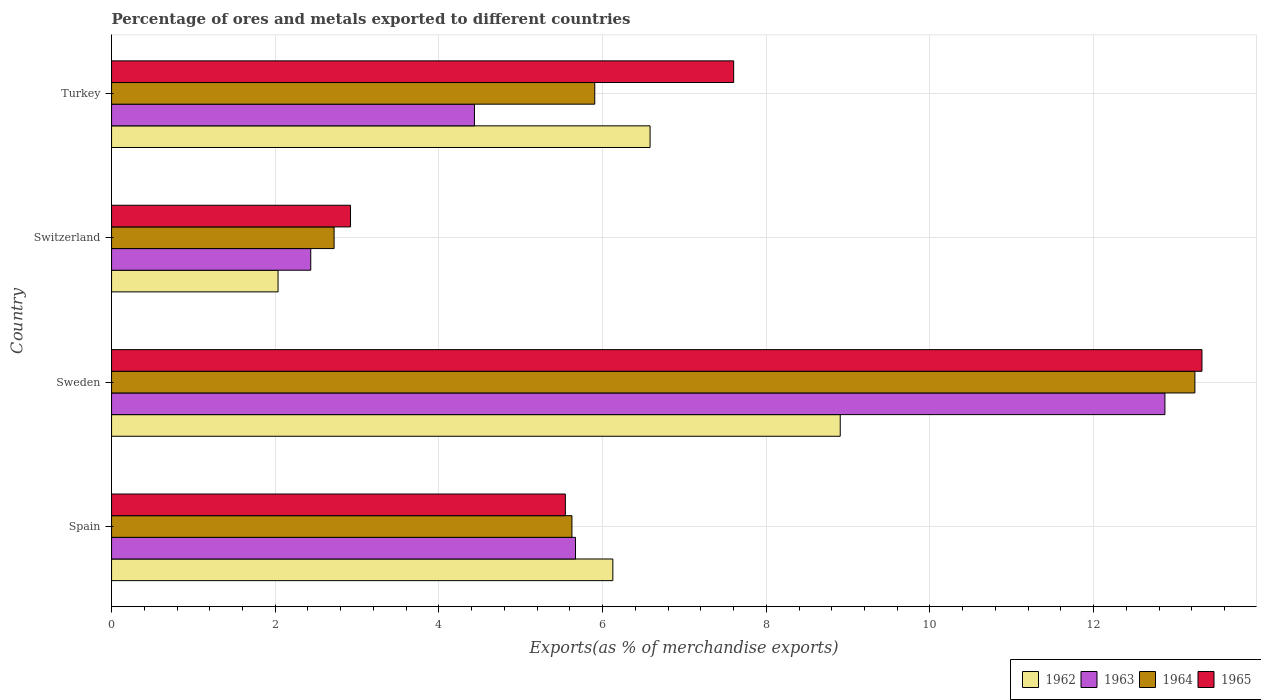How many different coloured bars are there?
Provide a short and direct response. 4. How many groups of bars are there?
Provide a succinct answer. 4. Are the number of bars per tick equal to the number of legend labels?
Make the answer very short. Yes. How many bars are there on the 2nd tick from the top?
Make the answer very short. 4. In how many cases, is the number of bars for a given country not equal to the number of legend labels?
Make the answer very short. 0. What is the percentage of exports to different countries in 1963 in Sweden?
Provide a short and direct response. 12.87. Across all countries, what is the maximum percentage of exports to different countries in 1965?
Your answer should be very brief. 13.32. Across all countries, what is the minimum percentage of exports to different countries in 1964?
Make the answer very short. 2.72. In which country was the percentage of exports to different countries in 1963 maximum?
Offer a very short reply. Sweden. In which country was the percentage of exports to different countries in 1965 minimum?
Your answer should be compact. Switzerland. What is the total percentage of exports to different countries in 1964 in the graph?
Make the answer very short. 27.49. What is the difference between the percentage of exports to different countries in 1962 in Switzerland and that in Turkey?
Your response must be concise. -4.55. What is the difference between the percentage of exports to different countries in 1964 in Switzerland and the percentage of exports to different countries in 1962 in Sweden?
Give a very brief answer. -6.18. What is the average percentage of exports to different countries in 1962 per country?
Provide a succinct answer. 5.91. What is the difference between the percentage of exports to different countries in 1962 and percentage of exports to different countries in 1963 in Turkey?
Your response must be concise. 2.15. In how many countries, is the percentage of exports to different countries in 1962 greater than 3.2 %?
Give a very brief answer. 3. What is the ratio of the percentage of exports to different countries in 1964 in Switzerland to that in Turkey?
Your response must be concise. 0.46. Is the percentage of exports to different countries in 1965 in Spain less than that in Turkey?
Offer a terse response. Yes. Is the difference between the percentage of exports to different countries in 1962 in Spain and Switzerland greater than the difference between the percentage of exports to different countries in 1963 in Spain and Switzerland?
Provide a succinct answer. Yes. What is the difference between the highest and the second highest percentage of exports to different countries in 1965?
Keep it short and to the point. 5.72. What is the difference between the highest and the lowest percentage of exports to different countries in 1963?
Offer a very short reply. 10.44. In how many countries, is the percentage of exports to different countries in 1965 greater than the average percentage of exports to different countries in 1965 taken over all countries?
Your answer should be very brief. 2. What does the 4th bar from the top in Turkey represents?
Offer a very short reply. 1962. Is it the case that in every country, the sum of the percentage of exports to different countries in 1965 and percentage of exports to different countries in 1963 is greater than the percentage of exports to different countries in 1962?
Keep it short and to the point. Yes. How many bars are there?
Ensure brevity in your answer.  16. Are all the bars in the graph horizontal?
Your response must be concise. Yes. How many countries are there in the graph?
Make the answer very short. 4. Does the graph contain grids?
Your answer should be compact. Yes. Where does the legend appear in the graph?
Give a very brief answer. Bottom right. How many legend labels are there?
Keep it short and to the point. 4. How are the legend labels stacked?
Keep it short and to the point. Horizontal. What is the title of the graph?
Offer a terse response. Percentage of ores and metals exported to different countries. What is the label or title of the X-axis?
Offer a terse response. Exports(as % of merchandise exports). What is the label or title of the Y-axis?
Make the answer very short. Country. What is the Exports(as % of merchandise exports) in 1962 in Spain?
Offer a very short reply. 6.13. What is the Exports(as % of merchandise exports) in 1963 in Spain?
Offer a very short reply. 5.67. What is the Exports(as % of merchandise exports) of 1964 in Spain?
Your response must be concise. 5.63. What is the Exports(as % of merchandise exports) in 1965 in Spain?
Offer a terse response. 5.55. What is the Exports(as % of merchandise exports) of 1962 in Sweden?
Your response must be concise. 8.9. What is the Exports(as % of merchandise exports) of 1963 in Sweden?
Offer a terse response. 12.87. What is the Exports(as % of merchandise exports) in 1964 in Sweden?
Your response must be concise. 13.24. What is the Exports(as % of merchandise exports) of 1965 in Sweden?
Make the answer very short. 13.32. What is the Exports(as % of merchandise exports) of 1962 in Switzerland?
Offer a very short reply. 2.03. What is the Exports(as % of merchandise exports) of 1963 in Switzerland?
Make the answer very short. 2.43. What is the Exports(as % of merchandise exports) of 1964 in Switzerland?
Give a very brief answer. 2.72. What is the Exports(as % of merchandise exports) in 1965 in Switzerland?
Give a very brief answer. 2.92. What is the Exports(as % of merchandise exports) of 1962 in Turkey?
Keep it short and to the point. 6.58. What is the Exports(as % of merchandise exports) of 1963 in Turkey?
Your response must be concise. 4.43. What is the Exports(as % of merchandise exports) of 1964 in Turkey?
Ensure brevity in your answer.  5.9. What is the Exports(as % of merchandise exports) of 1965 in Turkey?
Give a very brief answer. 7.6. Across all countries, what is the maximum Exports(as % of merchandise exports) of 1962?
Your response must be concise. 8.9. Across all countries, what is the maximum Exports(as % of merchandise exports) in 1963?
Ensure brevity in your answer.  12.87. Across all countries, what is the maximum Exports(as % of merchandise exports) of 1964?
Your response must be concise. 13.24. Across all countries, what is the maximum Exports(as % of merchandise exports) of 1965?
Your answer should be compact. 13.32. Across all countries, what is the minimum Exports(as % of merchandise exports) of 1962?
Provide a short and direct response. 2.03. Across all countries, what is the minimum Exports(as % of merchandise exports) of 1963?
Your answer should be very brief. 2.43. Across all countries, what is the minimum Exports(as % of merchandise exports) of 1964?
Offer a very short reply. 2.72. Across all countries, what is the minimum Exports(as % of merchandise exports) in 1965?
Give a very brief answer. 2.92. What is the total Exports(as % of merchandise exports) in 1962 in the graph?
Give a very brief answer. 23.64. What is the total Exports(as % of merchandise exports) in 1963 in the graph?
Offer a terse response. 25.41. What is the total Exports(as % of merchandise exports) in 1964 in the graph?
Provide a short and direct response. 27.49. What is the total Exports(as % of merchandise exports) in 1965 in the graph?
Make the answer very short. 29.39. What is the difference between the Exports(as % of merchandise exports) of 1962 in Spain and that in Sweden?
Your answer should be very brief. -2.78. What is the difference between the Exports(as % of merchandise exports) of 1963 in Spain and that in Sweden?
Provide a short and direct response. -7.2. What is the difference between the Exports(as % of merchandise exports) in 1964 in Spain and that in Sweden?
Ensure brevity in your answer.  -7.61. What is the difference between the Exports(as % of merchandise exports) in 1965 in Spain and that in Sweden?
Ensure brevity in your answer.  -7.78. What is the difference between the Exports(as % of merchandise exports) in 1962 in Spain and that in Switzerland?
Ensure brevity in your answer.  4.09. What is the difference between the Exports(as % of merchandise exports) of 1963 in Spain and that in Switzerland?
Keep it short and to the point. 3.24. What is the difference between the Exports(as % of merchandise exports) of 1964 in Spain and that in Switzerland?
Your response must be concise. 2.91. What is the difference between the Exports(as % of merchandise exports) of 1965 in Spain and that in Switzerland?
Ensure brevity in your answer.  2.63. What is the difference between the Exports(as % of merchandise exports) of 1962 in Spain and that in Turkey?
Your answer should be compact. -0.46. What is the difference between the Exports(as % of merchandise exports) of 1963 in Spain and that in Turkey?
Give a very brief answer. 1.23. What is the difference between the Exports(as % of merchandise exports) of 1964 in Spain and that in Turkey?
Provide a succinct answer. -0.28. What is the difference between the Exports(as % of merchandise exports) in 1965 in Spain and that in Turkey?
Ensure brevity in your answer.  -2.06. What is the difference between the Exports(as % of merchandise exports) in 1962 in Sweden and that in Switzerland?
Keep it short and to the point. 6.87. What is the difference between the Exports(as % of merchandise exports) of 1963 in Sweden and that in Switzerland?
Your answer should be compact. 10.44. What is the difference between the Exports(as % of merchandise exports) in 1964 in Sweden and that in Switzerland?
Make the answer very short. 10.52. What is the difference between the Exports(as % of merchandise exports) in 1965 in Sweden and that in Switzerland?
Your answer should be compact. 10.4. What is the difference between the Exports(as % of merchandise exports) of 1962 in Sweden and that in Turkey?
Your answer should be compact. 2.32. What is the difference between the Exports(as % of merchandise exports) of 1963 in Sweden and that in Turkey?
Provide a short and direct response. 8.44. What is the difference between the Exports(as % of merchandise exports) in 1964 in Sweden and that in Turkey?
Provide a short and direct response. 7.33. What is the difference between the Exports(as % of merchandise exports) in 1965 in Sweden and that in Turkey?
Ensure brevity in your answer.  5.72. What is the difference between the Exports(as % of merchandise exports) of 1962 in Switzerland and that in Turkey?
Provide a succinct answer. -4.55. What is the difference between the Exports(as % of merchandise exports) in 1963 in Switzerland and that in Turkey?
Your response must be concise. -2. What is the difference between the Exports(as % of merchandise exports) in 1964 in Switzerland and that in Turkey?
Provide a short and direct response. -3.19. What is the difference between the Exports(as % of merchandise exports) in 1965 in Switzerland and that in Turkey?
Your answer should be compact. -4.68. What is the difference between the Exports(as % of merchandise exports) in 1962 in Spain and the Exports(as % of merchandise exports) in 1963 in Sweden?
Your answer should be compact. -6.75. What is the difference between the Exports(as % of merchandise exports) of 1962 in Spain and the Exports(as % of merchandise exports) of 1964 in Sweden?
Your response must be concise. -7.11. What is the difference between the Exports(as % of merchandise exports) in 1962 in Spain and the Exports(as % of merchandise exports) in 1965 in Sweden?
Your answer should be very brief. -7.2. What is the difference between the Exports(as % of merchandise exports) in 1963 in Spain and the Exports(as % of merchandise exports) in 1964 in Sweden?
Give a very brief answer. -7.57. What is the difference between the Exports(as % of merchandise exports) in 1963 in Spain and the Exports(as % of merchandise exports) in 1965 in Sweden?
Ensure brevity in your answer.  -7.65. What is the difference between the Exports(as % of merchandise exports) in 1964 in Spain and the Exports(as % of merchandise exports) in 1965 in Sweden?
Make the answer very short. -7.7. What is the difference between the Exports(as % of merchandise exports) in 1962 in Spain and the Exports(as % of merchandise exports) in 1963 in Switzerland?
Provide a succinct answer. 3.69. What is the difference between the Exports(as % of merchandise exports) in 1962 in Spain and the Exports(as % of merchandise exports) in 1964 in Switzerland?
Ensure brevity in your answer.  3.41. What is the difference between the Exports(as % of merchandise exports) of 1962 in Spain and the Exports(as % of merchandise exports) of 1965 in Switzerland?
Offer a very short reply. 3.21. What is the difference between the Exports(as % of merchandise exports) of 1963 in Spain and the Exports(as % of merchandise exports) of 1964 in Switzerland?
Provide a short and direct response. 2.95. What is the difference between the Exports(as % of merchandise exports) in 1963 in Spain and the Exports(as % of merchandise exports) in 1965 in Switzerland?
Offer a very short reply. 2.75. What is the difference between the Exports(as % of merchandise exports) in 1964 in Spain and the Exports(as % of merchandise exports) in 1965 in Switzerland?
Provide a succinct answer. 2.71. What is the difference between the Exports(as % of merchandise exports) of 1962 in Spain and the Exports(as % of merchandise exports) of 1963 in Turkey?
Your answer should be compact. 1.69. What is the difference between the Exports(as % of merchandise exports) in 1962 in Spain and the Exports(as % of merchandise exports) in 1964 in Turkey?
Your response must be concise. 0.22. What is the difference between the Exports(as % of merchandise exports) of 1962 in Spain and the Exports(as % of merchandise exports) of 1965 in Turkey?
Make the answer very short. -1.48. What is the difference between the Exports(as % of merchandise exports) of 1963 in Spain and the Exports(as % of merchandise exports) of 1964 in Turkey?
Ensure brevity in your answer.  -0.23. What is the difference between the Exports(as % of merchandise exports) in 1963 in Spain and the Exports(as % of merchandise exports) in 1965 in Turkey?
Give a very brief answer. -1.93. What is the difference between the Exports(as % of merchandise exports) in 1964 in Spain and the Exports(as % of merchandise exports) in 1965 in Turkey?
Make the answer very short. -1.98. What is the difference between the Exports(as % of merchandise exports) in 1962 in Sweden and the Exports(as % of merchandise exports) in 1963 in Switzerland?
Offer a very short reply. 6.47. What is the difference between the Exports(as % of merchandise exports) of 1962 in Sweden and the Exports(as % of merchandise exports) of 1964 in Switzerland?
Your answer should be very brief. 6.18. What is the difference between the Exports(as % of merchandise exports) in 1962 in Sweden and the Exports(as % of merchandise exports) in 1965 in Switzerland?
Offer a terse response. 5.98. What is the difference between the Exports(as % of merchandise exports) of 1963 in Sweden and the Exports(as % of merchandise exports) of 1964 in Switzerland?
Give a very brief answer. 10.15. What is the difference between the Exports(as % of merchandise exports) in 1963 in Sweden and the Exports(as % of merchandise exports) in 1965 in Switzerland?
Offer a terse response. 9.95. What is the difference between the Exports(as % of merchandise exports) in 1964 in Sweden and the Exports(as % of merchandise exports) in 1965 in Switzerland?
Give a very brief answer. 10.32. What is the difference between the Exports(as % of merchandise exports) of 1962 in Sweden and the Exports(as % of merchandise exports) of 1963 in Turkey?
Provide a short and direct response. 4.47. What is the difference between the Exports(as % of merchandise exports) in 1962 in Sweden and the Exports(as % of merchandise exports) in 1964 in Turkey?
Your answer should be compact. 3. What is the difference between the Exports(as % of merchandise exports) of 1962 in Sweden and the Exports(as % of merchandise exports) of 1965 in Turkey?
Ensure brevity in your answer.  1.3. What is the difference between the Exports(as % of merchandise exports) of 1963 in Sweden and the Exports(as % of merchandise exports) of 1964 in Turkey?
Provide a short and direct response. 6.97. What is the difference between the Exports(as % of merchandise exports) of 1963 in Sweden and the Exports(as % of merchandise exports) of 1965 in Turkey?
Offer a very short reply. 5.27. What is the difference between the Exports(as % of merchandise exports) of 1964 in Sweden and the Exports(as % of merchandise exports) of 1965 in Turkey?
Ensure brevity in your answer.  5.64. What is the difference between the Exports(as % of merchandise exports) in 1962 in Switzerland and the Exports(as % of merchandise exports) in 1963 in Turkey?
Provide a succinct answer. -2.4. What is the difference between the Exports(as % of merchandise exports) of 1962 in Switzerland and the Exports(as % of merchandise exports) of 1964 in Turkey?
Make the answer very short. -3.87. What is the difference between the Exports(as % of merchandise exports) in 1962 in Switzerland and the Exports(as % of merchandise exports) in 1965 in Turkey?
Provide a short and direct response. -5.57. What is the difference between the Exports(as % of merchandise exports) of 1963 in Switzerland and the Exports(as % of merchandise exports) of 1964 in Turkey?
Offer a very short reply. -3.47. What is the difference between the Exports(as % of merchandise exports) in 1963 in Switzerland and the Exports(as % of merchandise exports) in 1965 in Turkey?
Offer a very short reply. -5.17. What is the difference between the Exports(as % of merchandise exports) in 1964 in Switzerland and the Exports(as % of merchandise exports) in 1965 in Turkey?
Ensure brevity in your answer.  -4.88. What is the average Exports(as % of merchandise exports) of 1962 per country?
Your answer should be compact. 5.91. What is the average Exports(as % of merchandise exports) in 1963 per country?
Provide a short and direct response. 6.35. What is the average Exports(as % of merchandise exports) in 1964 per country?
Ensure brevity in your answer.  6.87. What is the average Exports(as % of merchandise exports) in 1965 per country?
Make the answer very short. 7.35. What is the difference between the Exports(as % of merchandise exports) of 1962 and Exports(as % of merchandise exports) of 1963 in Spain?
Your answer should be compact. 0.46. What is the difference between the Exports(as % of merchandise exports) of 1962 and Exports(as % of merchandise exports) of 1964 in Spain?
Offer a terse response. 0.5. What is the difference between the Exports(as % of merchandise exports) of 1962 and Exports(as % of merchandise exports) of 1965 in Spain?
Your response must be concise. 0.58. What is the difference between the Exports(as % of merchandise exports) of 1963 and Exports(as % of merchandise exports) of 1964 in Spain?
Your answer should be very brief. 0.04. What is the difference between the Exports(as % of merchandise exports) in 1963 and Exports(as % of merchandise exports) in 1965 in Spain?
Give a very brief answer. 0.12. What is the difference between the Exports(as % of merchandise exports) of 1964 and Exports(as % of merchandise exports) of 1965 in Spain?
Make the answer very short. 0.08. What is the difference between the Exports(as % of merchandise exports) of 1962 and Exports(as % of merchandise exports) of 1963 in Sweden?
Keep it short and to the point. -3.97. What is the difference between the Exports(as % of merchandise exports) in 1962 and Exports(as % of merchandise exports) in 1964 in Sweden?
Your response must be concise. -4.33. What is the difference between the Exports(as % of merchandise exports) of 1962 and Exports(as % of merchandise exports) of 1965 in Sweden?
Provide a short and direct response. -4.42. What is the difference between the Exports(as % of merchandise exports) of 1963 and Exports(as % of merchandise exports) of 1964 in Sweden?
Your answer should be compact. -0.37. What is the difference between the Exports(as % of merchandise exports) of 1963 and Exports(as % of merchandise exports) of 1965 in Sweden?
Give a very brief answer. -0.45. What is the difference between the Exports(as % of merchandise exports) of 1964 and Exports(as % of merchandise exports) of 1965 in Sweden?
Ensure brevity in your answer.  -0.09. What is the difference between the Exports(as % of merchandise exports) in 1962 and Exports(as % of merchandise exports) in 1963 in Switzerland?
Provide a succinct answer. -0.4. What is the difference between the Exports(as % of merchandise exports) of 1962 and Exports(as % of merchandise exports) of 1964 in Switzerland?
Make the answer very short. -0.68. What is the difference between the Exports(as % of merchandise exports) in 1962 and Exports(as % of merchandise exports) in 1965 in Switzerland?
Keep it short and to the point. -0.89. What is the difference between the Exports(as % of merchandise exports) of 1963 and Exports(as % of merchandise exports) of 1964 in Switzerland?
Make the answer very short. -0.29. What is the difference between the Exports(as % of merchandise exports) in 1963 and Exports(as % of merchandise exports) in 1965 in Switzerland?
Keep it short and to the point. -0.49. What is the difference between the Exports(as % of merchandise exports) of 1964 and Exports(as % of merchandise exports) of 1965 in Switzerland?
Your response must be concise. -0.2. What is the difference between the Exports(as % of merchandise exports) of 1962 and Exports(as % of merchandise exports) of 1963 in Turkey?
Your answer should be very brief. 2.15. What is the difference between the Exports(as % of merchandise exports) in 1962 and Exports(as % of merchandise exports) in 1964 in Turkey?
Your answer should be compact. 0.68. What is the difference between the Exports(as % of merchandise exports) in 1962 and Exports(as % of merchandise exports) in 1965 in Turkey?
Your answer should be compact. -1.02. What is the difference between the Exports(as % of merchandise exports) in 1963 and Exports(as % of merchandise exports) in 1964 in Turkey?
Ensure brevity in your answer.  -1.47. What is the difference between the Exports(as % of merchandise exports) in 1963 and Exports(as % of merchandise exports) in 1965 in Turkey?
Offer a terse response. -3.17. What is the difference between the Exports(as % of merchandise exports) of 1964 and Exports(as % of merchandise exports) of 1965 in Turkey?
Your answer should be very brief. -1.7. What is the ratio of the Exports(as % of merchandise exports) of 1962 in Spain to that in Sweden?
Your response must be concise. 0.69. What is the ratio of the Exports(as % of merchandise exports) of 1963 in Spain to that in Sweden?
Your answer should be very brief. 0.44. What is the ratio of the Exports(as % of merchandise exports) in 1964 in Spain to that in Sweden?
Offer a terse response. 0.42. What is the ratio of the Exports(as % of merchandise exports) of 1965 in Spain to that in Sweden?
Your answer should be compact. 0.42. What is the ratio of the Exports(as % of merchandise exports) in 1962 in Spain to that in Switzerland?
Offer a very short reply. 3.01. What is the ratio of the Exports(as % of merchandise exports) in 1963 in Spain to that in Switzerland?
Keep it short and to the point. 2.33. What is the ratio of the Exports(as % of merchandise exports) in 1964 in Spain to that in Switzerland?
Give a very brief answer. 2.07. What is the ratio of the Exports(as % of merchandise exports) in 1965 in Spain to that in Switzerland?
Your response must be concise. 1.9. What is the ratio of the Exports(as % of merchandise exports) in 1962 in Spain to that in Turkey?
Ensure brevity in your answer.  0.93. What is the ratio of the Exports(as % of merchandise exports) in 1963 in Spain to that in Turkey?
Provide a short and direct response. 1.28. What is the ratio of the Exports(as % of merchandise exports) of 1964 in Spain to that in Turkey?
Provide a succinct answer. 0.95. What is the ratio of the Exports(as % of merchandise exports) of 1965 in Spain to that in Turkey?
Ensure brevity in your answer.  0.73. What is the ratio of the Exports(as % of merchandise exports) of 1962 in Sweden to that in Switzerland?
Give a very brief answer. 4.38. What is the ratio of the Exports(as % of merchandise exports) of 1963 in Sweden to that in Switzerland?
Your answer should be compact. 5.29. What is the ratio of the Exports(as % of merchandise exports) in 1964 in Sweden to that in Switzerland?
Provide a succinct answer. 4.87. What is the ratio of the Exports(as % of merchandise exports) in 1965 in Sweden to that in Switzerland?
Ensure brevity in your answer.  4.56. What is the ratio of the Exports(as % of merchandise exports) of 1962 in Sweden to that in Turkey?
Keep it short and to the point. 1.35. What is the ratio of the Exports(as % of merchandise exports) in 1963 in Sweden to that in Turkey?
Your response must be concise. 2.9. What is the ratio of the Exports(as % of merchandise exports) of 1964 in Sweden to that in Turkey?
Your answer should be very brief. 2.24. What is the ratio of the Exports(as % of merchandise exports) in 1965 in Sweden to that in Turkey?
Offer a terse response. 1.75. What is the ratio of the Exports(as % of merchandise exports) in 1962 in Switzerland to that in Turkey?
Offer a terse response. 0.31. What is the ratio of the Exports(as % of merchandise exports) in 1963 in Switzerland to that in Turkey?
Your response must be concise. 0.55. What is the ratio of the Exports(as % of merchandise exports) of 1964 in Switzerland to that in Turkey?
Give a very brief answer. 0.46. What is the ratio of the Exports(as % of merchandise exports) in 1965 in Switzerland to that in Turkey?
Provide a succinct answer. 0.38. What is the difference between the highest and the second highest Exports(as % of merchandise exports) in 1962?
Offer a terse response. 2.32. What is the difference between the highest and the second highest Exports(as % of merchandise exports) in 1963?
Keep it short and to the point. 7.2. What is the difference between the highest and the second highest Exports(as % of merchandise exports) in 1964?
Make the answer very short. 7.33. What is the difference between the highest and the second highest Exports(as % of merchandise exports) in 1965?
Offer a terse response. 5.72. What is the difference between the highest and the lowest Exports(as % of merchandise exports) in 1962?
Provide a succinct answer. 6.87. What is the difference between the highest and the lowest Exports(as % of merchandise exports) in 1963?
Give a very brief answer. 10.44. What is the difference between the highest and the lowest Exports(as % of merchandise exports) of 1964?
Provide a short and direct response. 10.52. What is the difference between the highest and the lowest Exports(as % of merchandise exports) of 1965?
Keep it short and to the point. 10.4. 